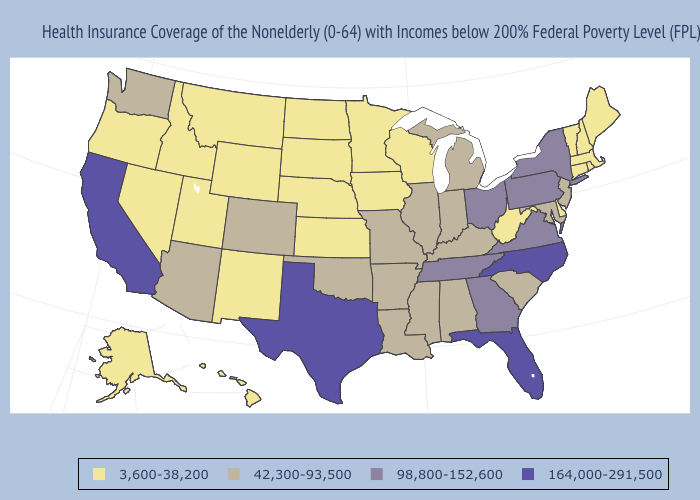What is the lowest value in the West?
Give a very brief answer. 3,600-38,200. What is the value of Wisconsin?
Answer briefly. 3,600-38,200. What is the lowest value in the USA?
Give a very brief answer. 3,600-38,200. Does Wisconsin have a lower value than North Dakota?
Quick response, please. No. Does Missouri have the highest value in the MidWest?
Short answer required. No. What is the value of Washington?
Be succinct. 42,300-93,500. What is the lowest value in states that border New Jersey?
Concise answer only. 3,600-38,200. Name the states that have a value in the range 42,300-93,500?
Short answer required. Alabama, Arizona, Arkansas, Colorado, Illinois, Indiana, Kentucky, Louisiana, Maryland, Michigan, Mississippi, Missouri, New Jersey, Oklahoma, South Carolina, Washington. What is the lowest value in the USA?
Give a very brief answer. 3,600-38,200. Name the states that have a value in the range 3,600-38,200?
Short answer required. Alaska, Connecticut, Delaware, Hawaii, Idaho, Iowa, Kansas, Maine, Massachusetts, Minnesota, Montana, Nebraska, Nevada, New Hampshire, New Mexico, North Dakota, Oregon, Rhode Island, South Dakota, Utah, Vermont, West Virginia, Wisconsin, Wyoming. Does the first symbol in the legend represent the smallest category?
Short answer required. Yes. What is the value of Alabama?
Be succinct. 42,300-93,500. What is the highest value in the South ?
Keep it brief. 164,000-291,500. Does Florida have the highest value in the USA?
Answer briefly. Yes. Does South Carolina have a lower value than Florida?
Keep it brief. Yes. 